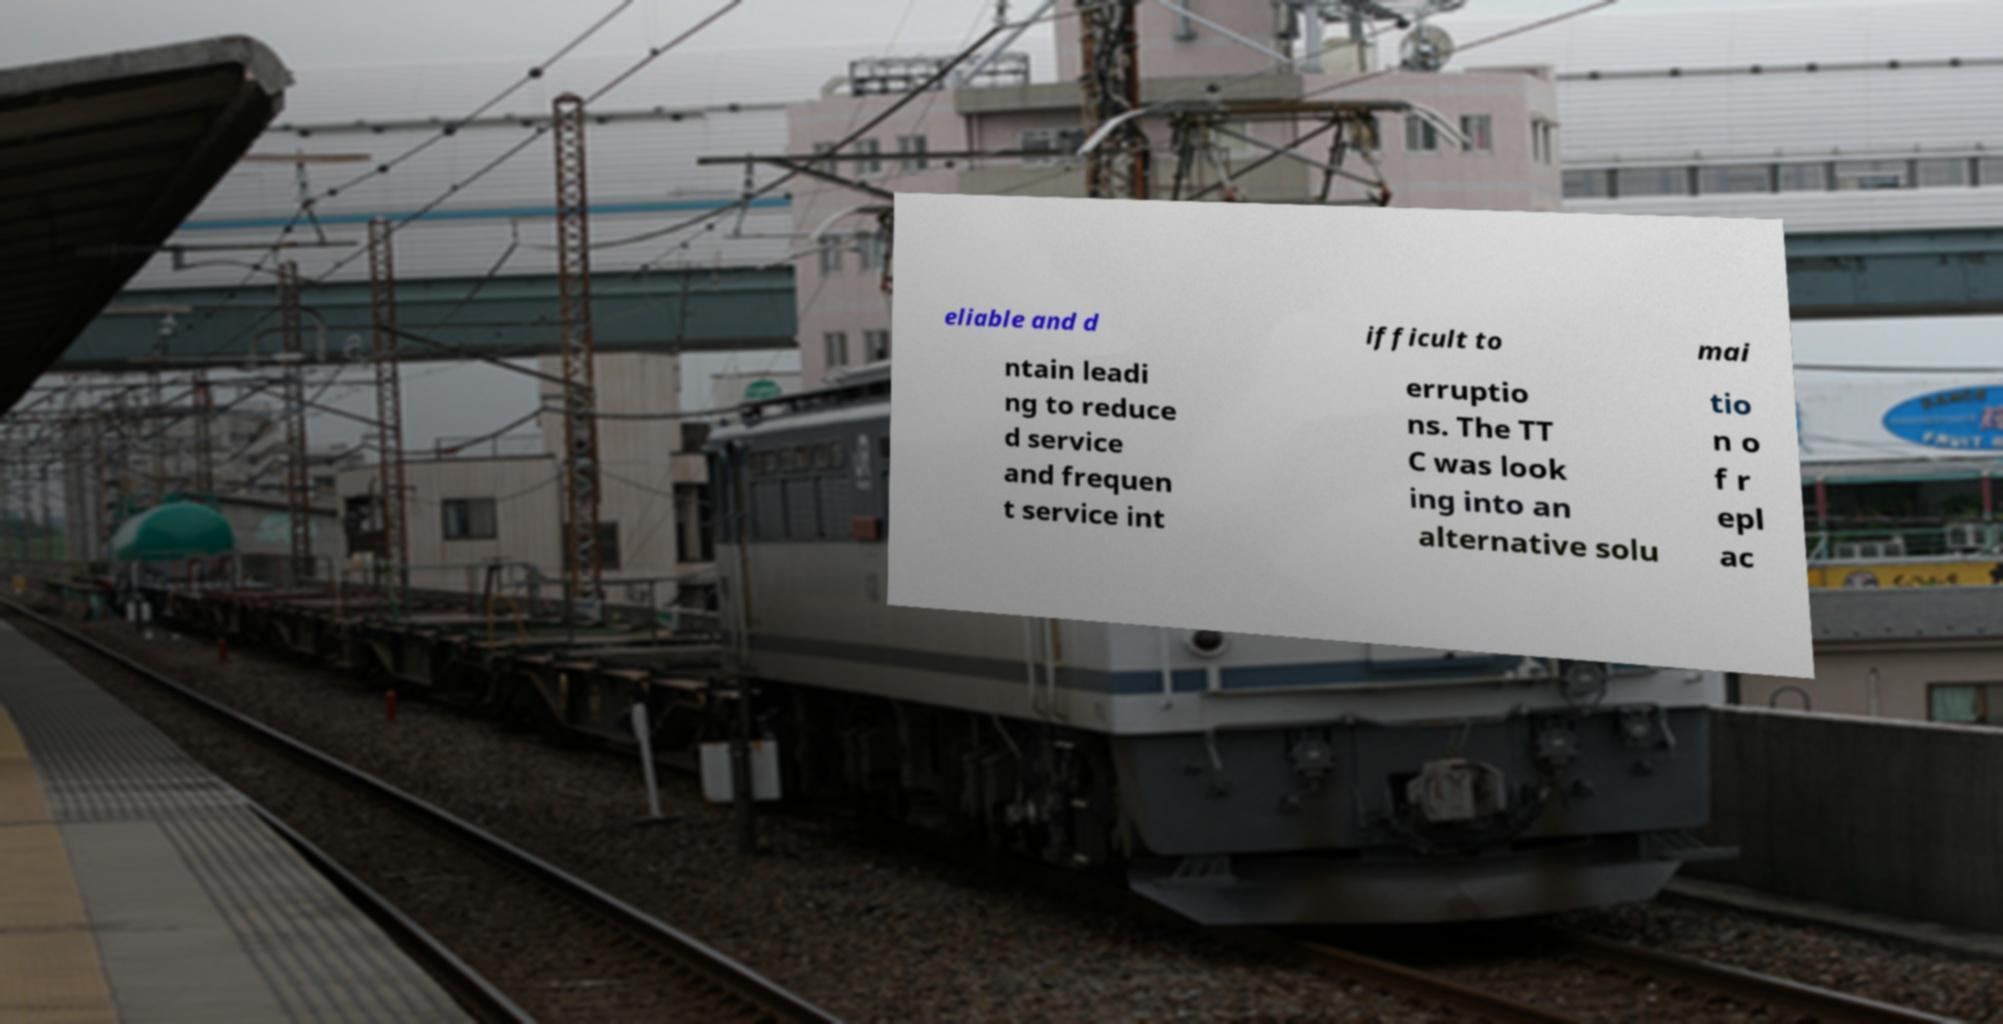Can you read and provide the text displayed in the image?This photo seems to have some interesting text. Can you extract and type it out for me? eliable and d ifficult to mai ntain leadi ng to reduce d service and frequen t service int erruptio ns. The TT C was look ing into an alternative solu tio n o f r epl ac 